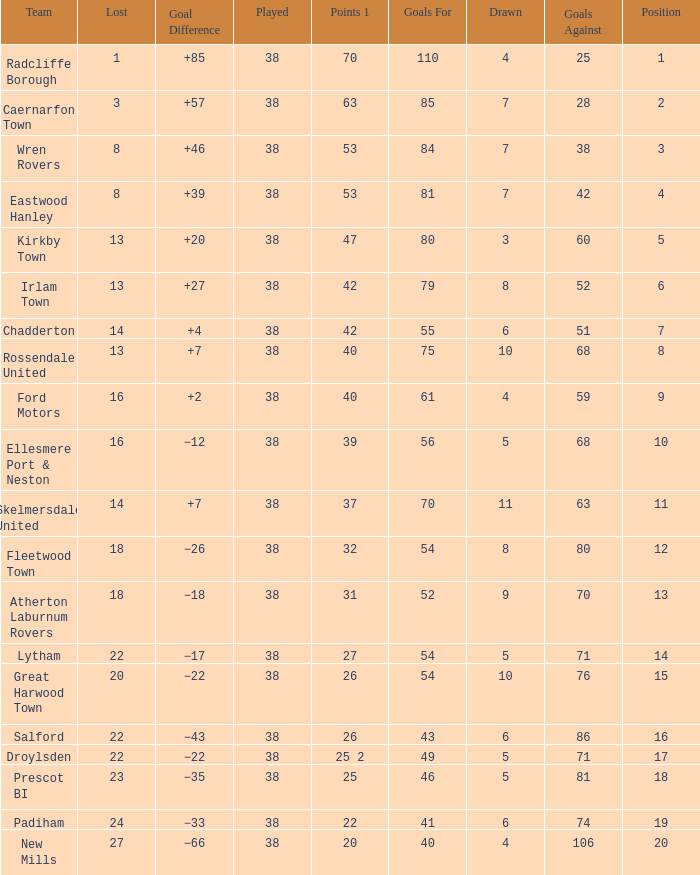How much Drawn has Goals Against larger than 74, and a Lost smaller than 20, and a Played larger than 38? 0.0. 